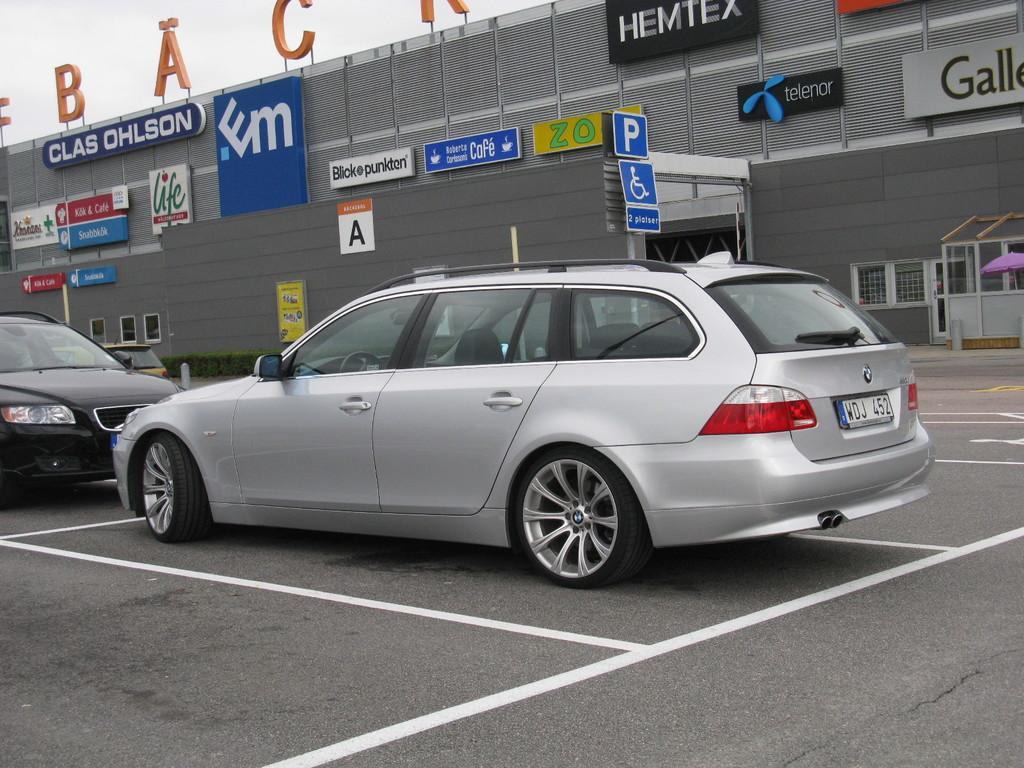<image>
Render a clear and concise summary of the photo. The outside of a car dealership with a Hemtex banner on it 